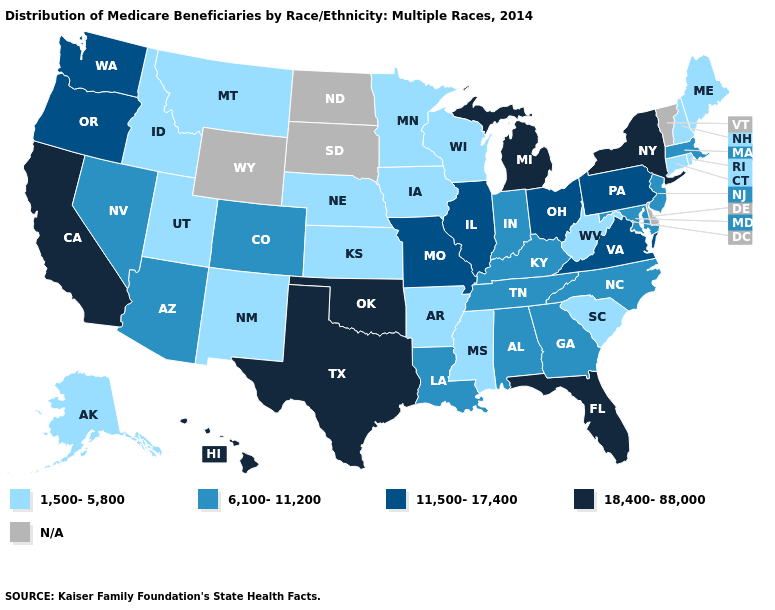Which states hav the highest value in the MidWest?
Write a very short answer. Michigan. Name the states that have a value in the range N/A?
Be succinct. Delaware, North Dakota, South Dakota, Vermont, Wyoming. Does the map have missing data?
Be succinct. Yes. What is the lowest value in states that border New Hampshire?
Be succinct. 1,500-5,800. What is the value of Louisiana?
Give a very brief answer. 6,100-11,200. Name the states that have a value in the range N/A?
Give a very brief answer. Delaware, North Dakota, South Dakota, Vermont, Wyoming. Does New Hampshire have the lowest value in the Northeast?
Keep it brief. Yes. What is the value of Iowa?
Short answer required. 1,500-5,800. Does Iowa have the lowest value in the MidWest?
Answer briefly. Yes. What is the value of Kansas?
Short answer required. 1,500-5,800. Name the states that have a value in the range 6,100-11,200?
Keep it brief. Alabama, Arizona, Colorado, Georgia, Indiana, Kentucky, Louisiana, Maryland, Massachusetts, Nevada, New Jersey, North Carolina, Tennessee. 